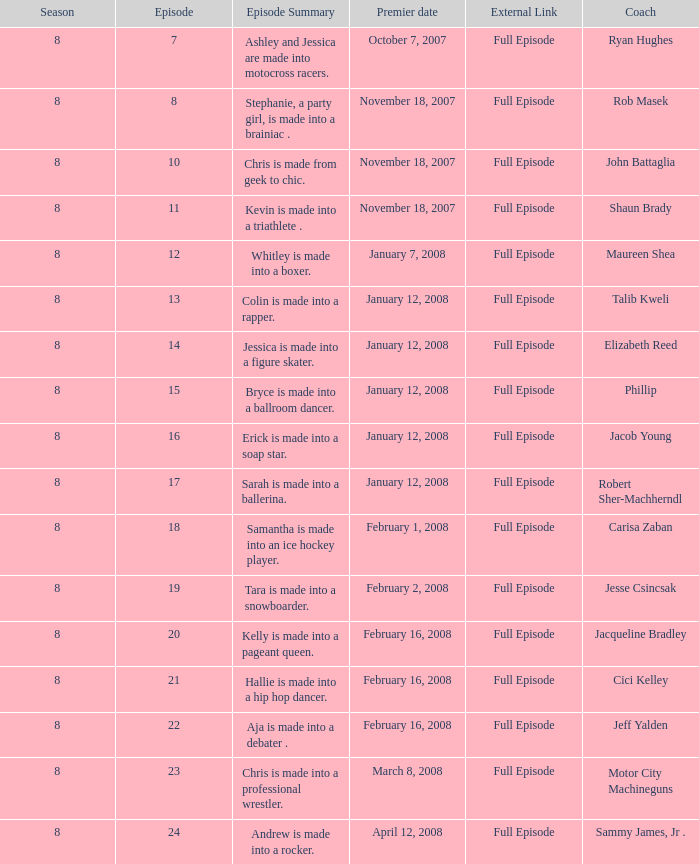What was Cici Kelley's minimum season? 8.0. 